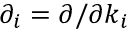<formula> <loc_0><loc_0><loc_500><loc_500>\partial _ { i } = \partial / \partial k _ { i }</formula> 